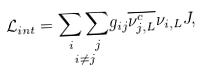<formula> <loc_0><loc_0><loc_500><loc_500>\mathcal { L } _ { i n t } = \underset { i \neq j } { \sum _ { i } \sum _ { j } } g _ { i j } \overline { { { \nu _ { j , L } ^ { c } } } } \nu _ { i , L } J ,</formula> 